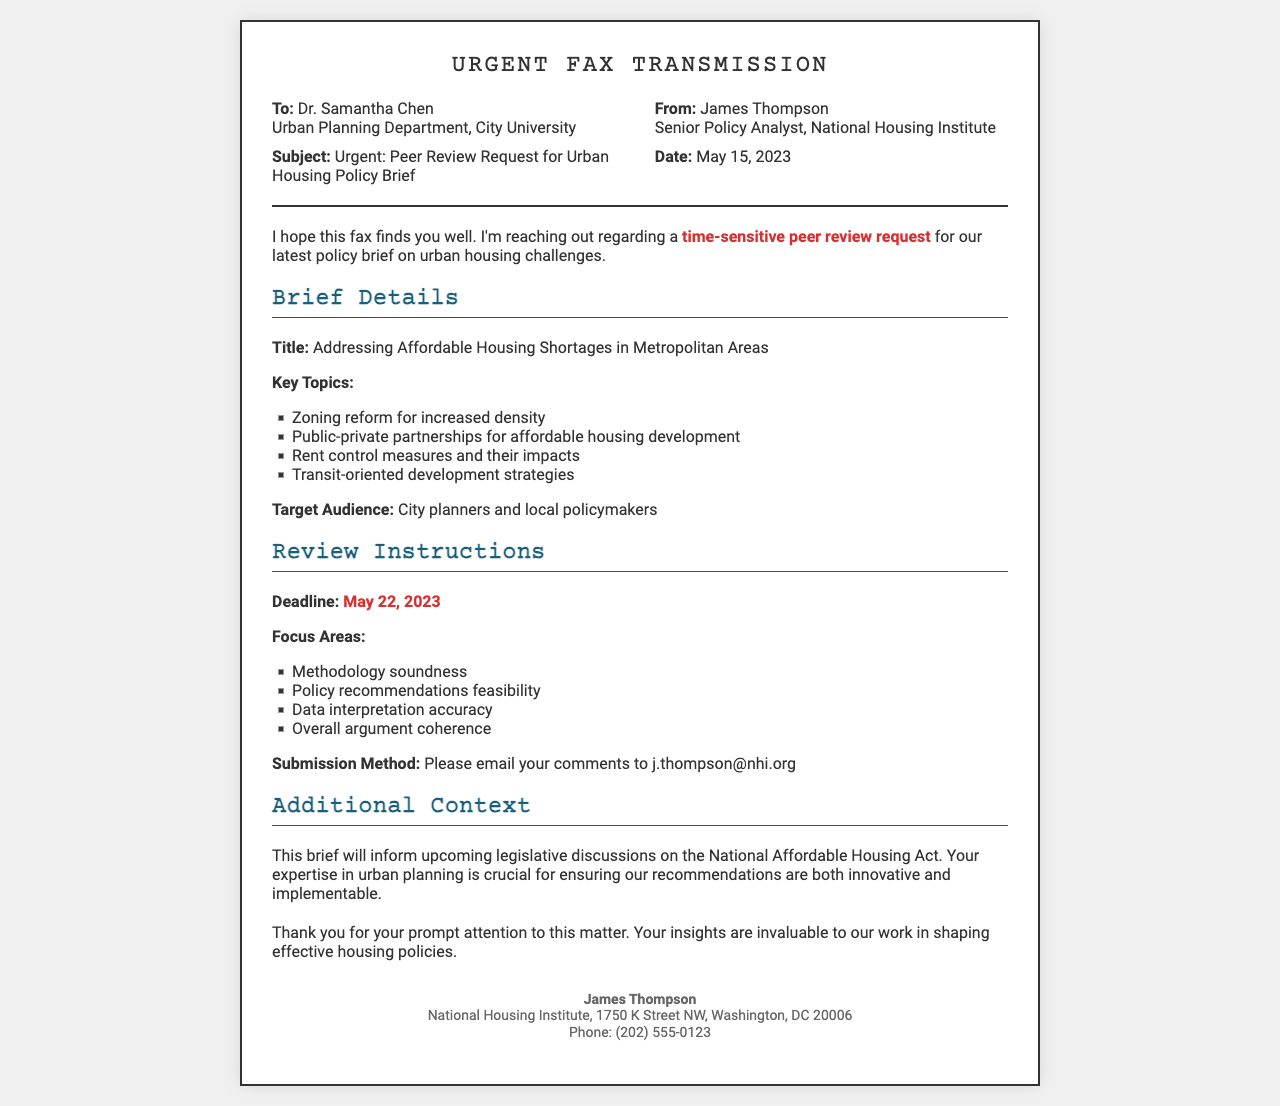what is the title of the policy brief? The title of the policy brief is specifically mentioned in the document as "Addressing Affordable Housing Shortages in Metropolitan Areas."
Answer: Addressing Affordable Housing Shortages in Metropolitan Areas who is the recipient of the fax? The recipient of the fax is identified as Dr. Samantha Chen, who is associated with the Urban Planning Department at City University.
Answer: Dr. Samantha Chen what is the submission method for peer review comments? The document specifies that comments should be emailed to j.thompson@nhi.org.
Answer: j.thompson@nhi.org what is the deadline for the peer review? The deadline for submitting the peer review comments is stated as May 22, 2023.
Answer: May 22, 2023 what are the key topics covered in the policy brief? The key topics include zoning reform for increased density, public-private partnerships for affordable housing development, rent control measures and their impacts, and transit-oriented development strategies.
Answer: Zoning reform for increased density, public-private partnerships for affordable housing development, rent control measures and their impacts, transit-oriented development strategies why is Dr. Samantha Chen's expertise requested? Dr. Samantha Chen's expertise is requested to ensure that the recommendations in the brief are innovative and implementable for the upcoming legislative discussions on the National Affordable Housing Act.
Answer: Innovative and implementable recommendations how many focus areas are listed for the review? The document lists four focus areas that are to be examined during the review.
Answer: Four who is the sender of the fax? The sender of the fax is James Thompson, who is a Senior Policy Analyst at the National Housing Institute.
Answer: James Thompson what organization is associated with the sender? The organization associated with the sender is the National Housing Institute.
Answer: National Housing Institute 